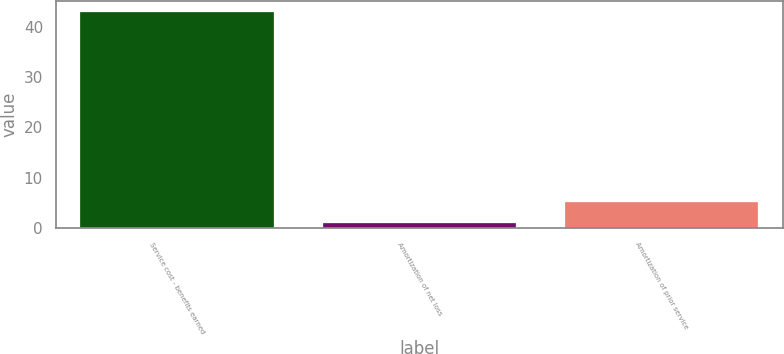Convert chart to OTSL. <chart><loc_0><loc_0><loc_500><loc_500><bar_chart><fcel>Service cost - benefits earned<fcel>Amortization of net loss<fcel>Amortization of prior service<nl><fcel>43<fcel>1<fcel>5.2<nl></chart> 